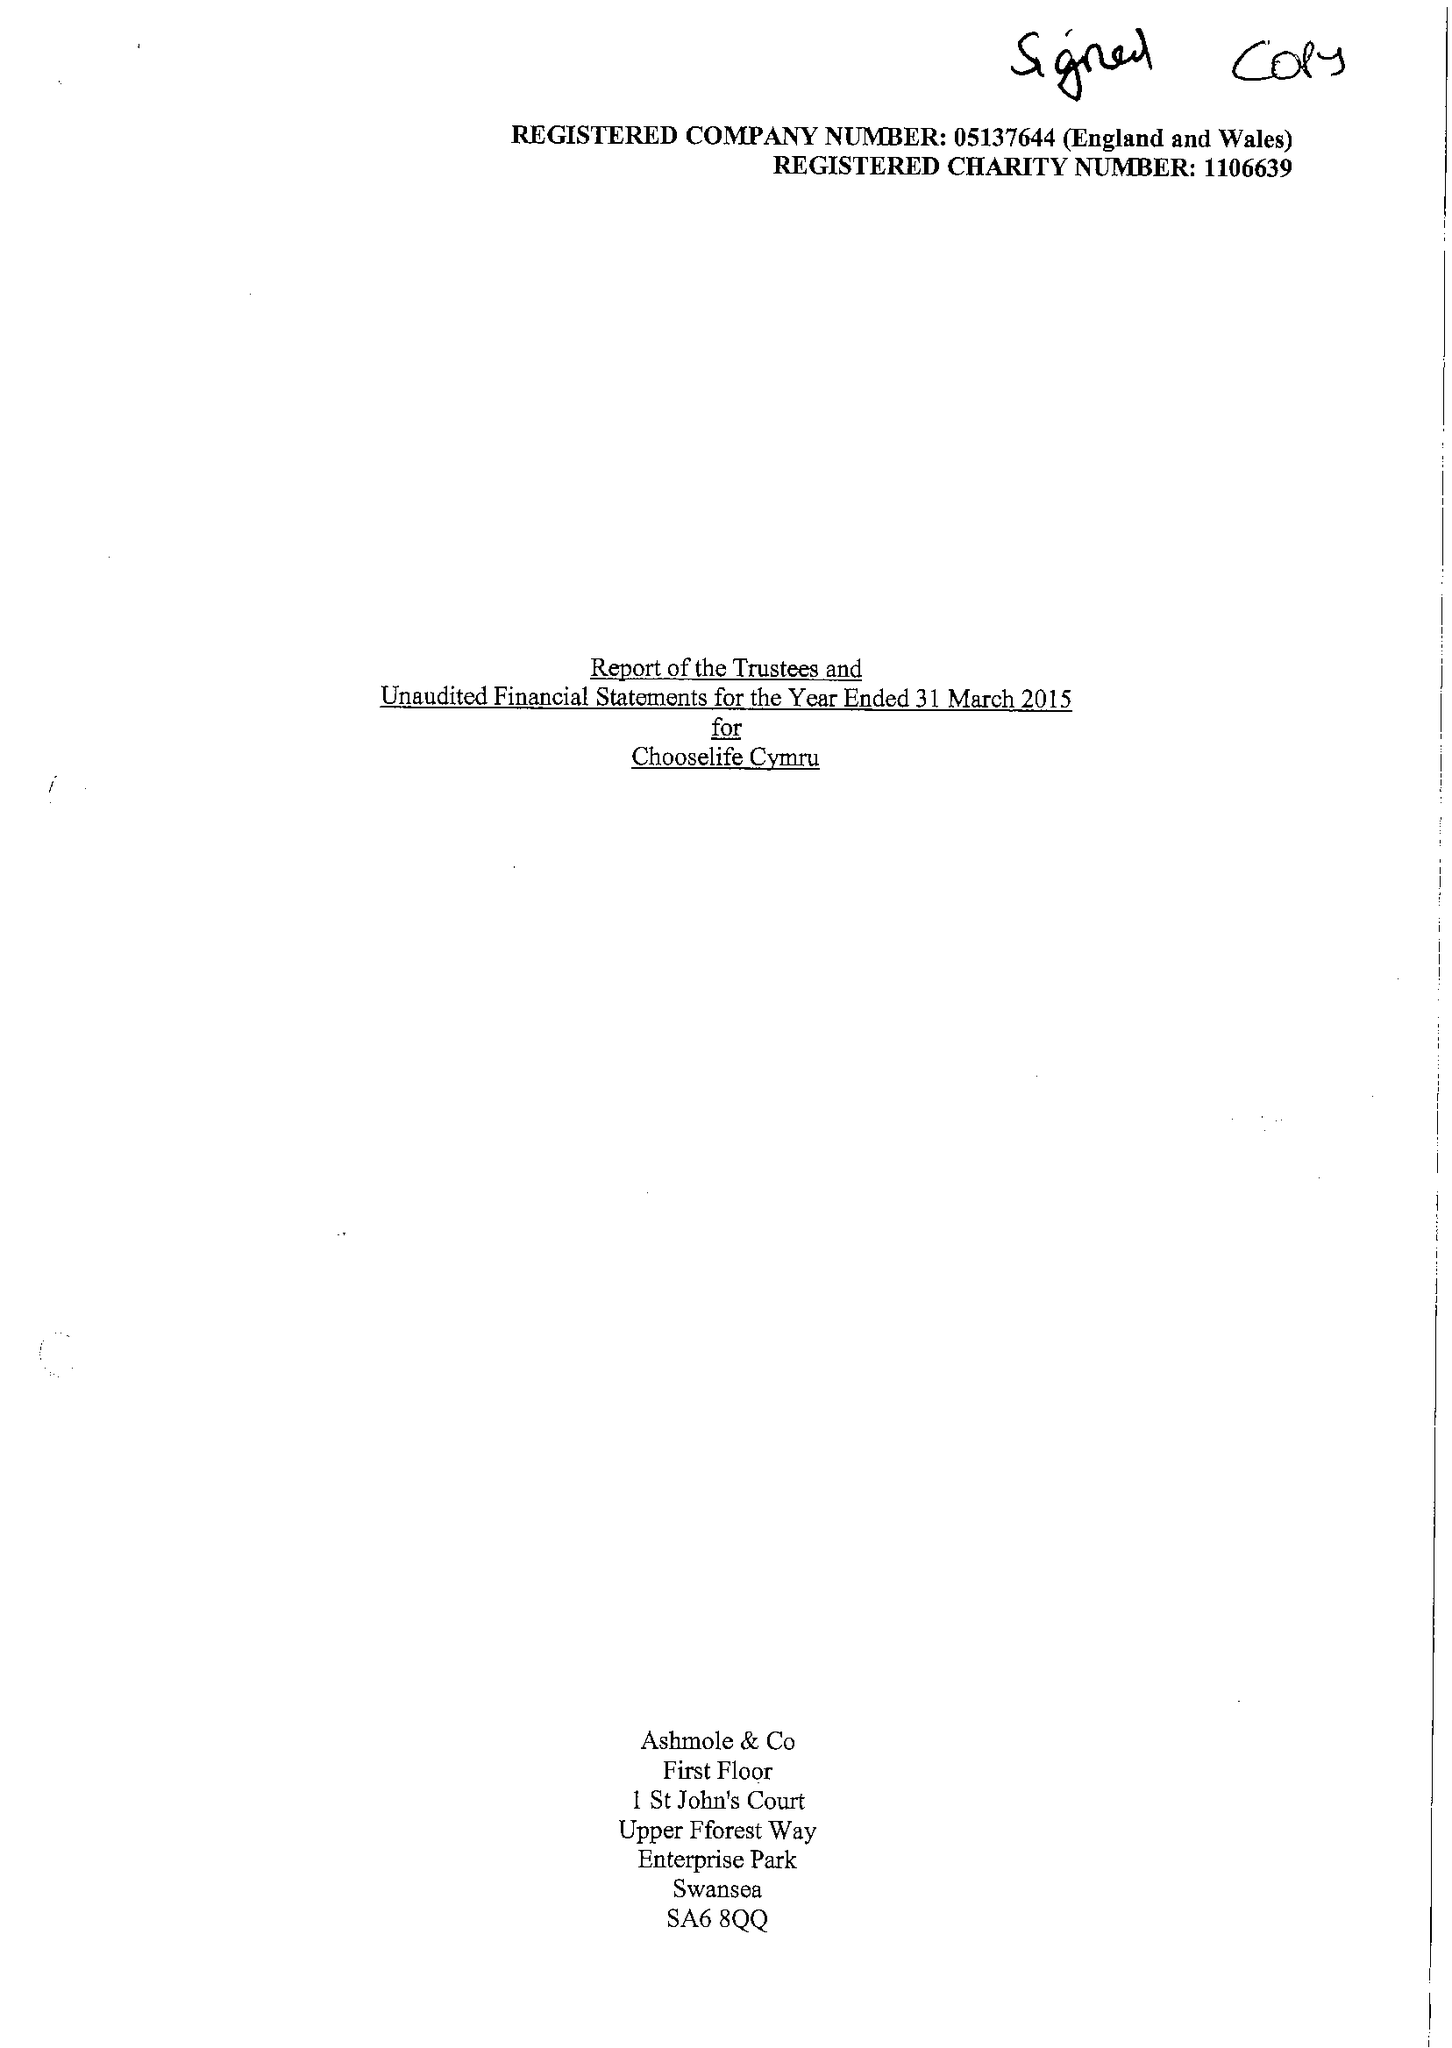What is the value for the address__post_town?
Answer the question using a single word or phrase. LLANELLI 